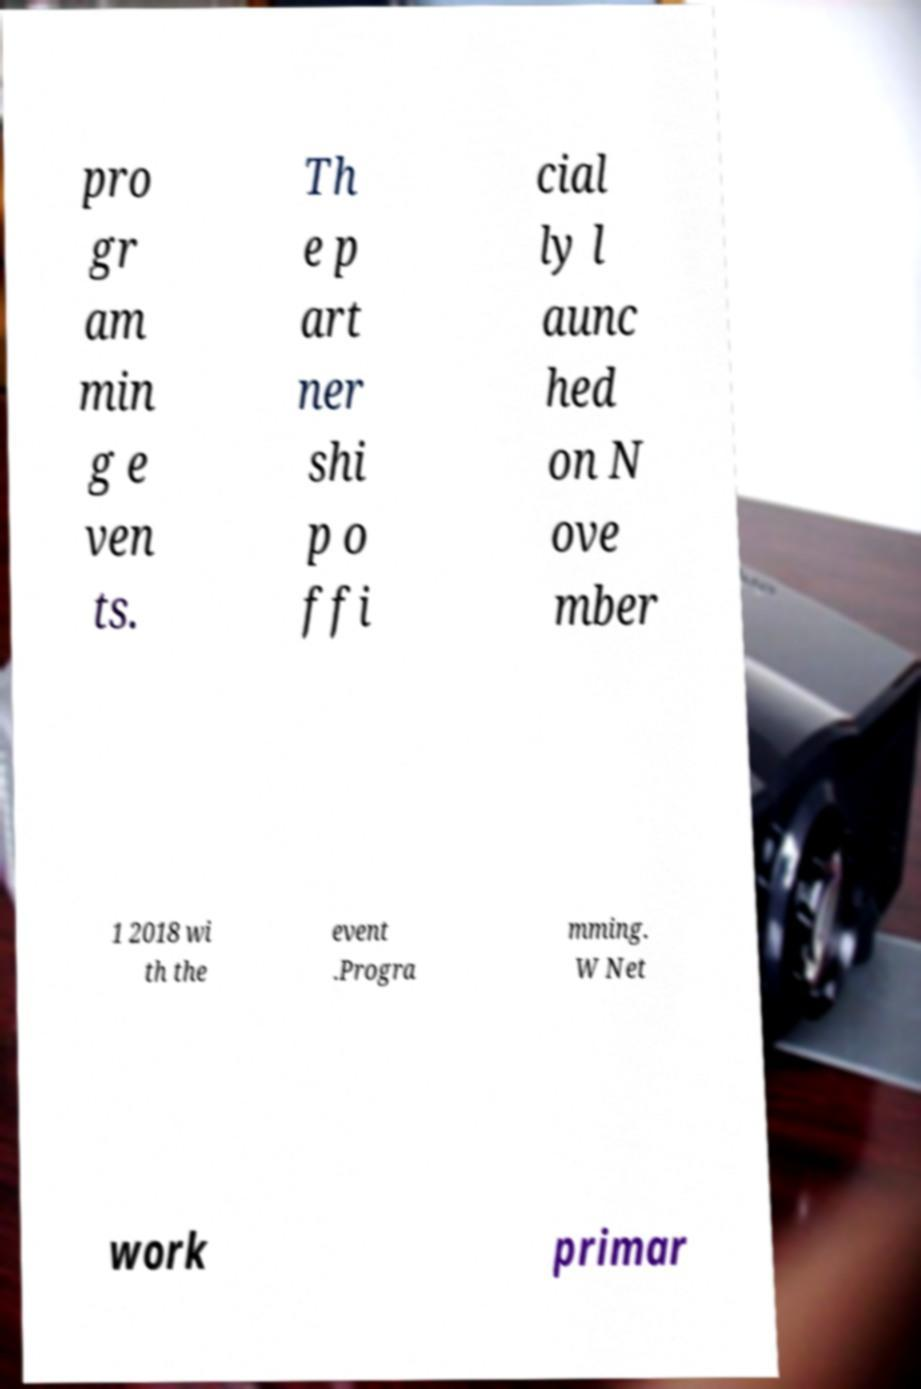Please read and relay the text visible in this image. What does it say? pro gr am min g e ven ts. Th e p art ner shi p o ffi cial ly l aunc hed on N ove mber 1 2018 wi th the event .Progra mming. W Net work primar 